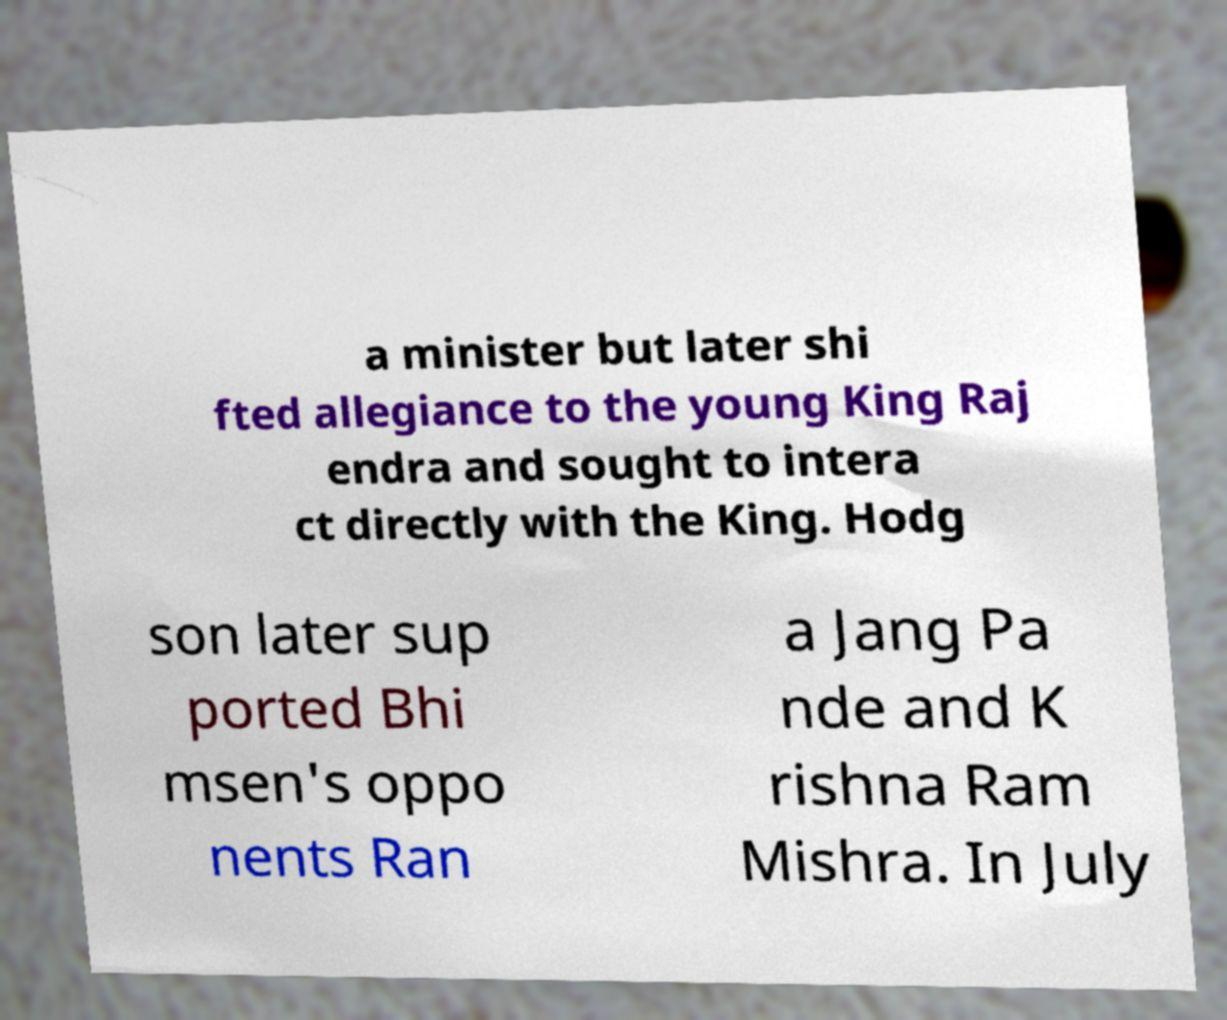Can you read and provide the text displayed in the image?This photo seems to have some interesting text. Can you extract and type it out for me? a minister but later shi fted allegiance to the young King Raj endra and sought to intera ct directly with the King. Hodg son later sup ported Bhi msen's oppo nents Ran a Jang Pa nde and K rishna Ram Mishra. In July 